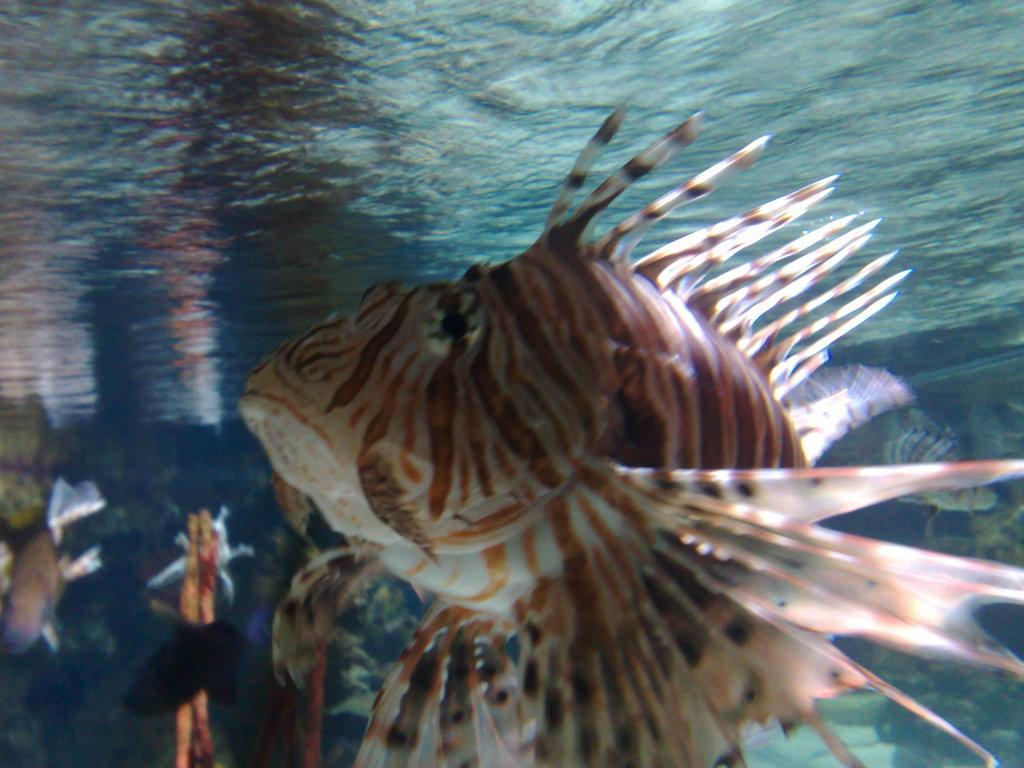What type of animal is in the image? There is a fish in the image. Can you describe the color of the fish? The fish is brown, cream, and pink in color. Where is the fish located in the image? The fish is underwater. What else can be seen in the image besides the fish? There are other aquatic animals visible in the background of the image. What type of verse can be heard recited by the cushion in the image? There is no cushion present in the image, and therefore no verses can be heard. 